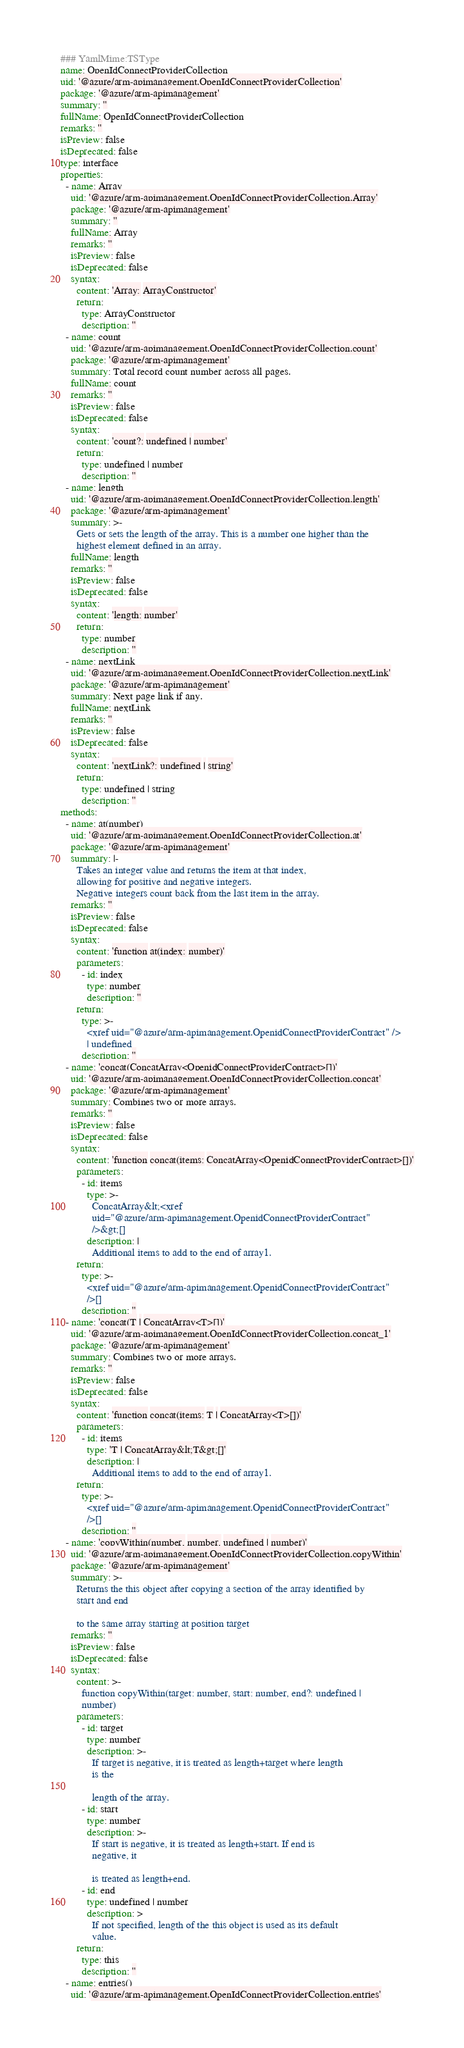<code> <loc_0><loc_0><loc_500><loc_500><_YAML_>### YamlMime:TSType
name: OpenIdConnectProviderCollection
uid: '@azure/arm-apimanagement.OpenIdConnectProviderCollection'
package: '@azure/arm-apimanagement'
summary: ''
fullName: OpenIdConnectProviderCollection
remarks: ''
isPreview: false
isDeprecated: false
type: interface
properties:
  - name: Array
    uid: '@azure/arm-apimanagement.OpenIdConnectProviderCollection.Array'
    package: '@azure/arm-apimanagement'
    summary: ''
    fullName: Array
    remarks: ''
    isPreview: false
    isDeprecated: false
    syntax:
      content: 'Array: ArrayConstructor'
      return:
        type: ArrayConstructor
        description: ''
  - name: count
    uid: '@azure/arm-apimanagement.OpenIdConnectProviderCollection.count'
    package: '@azure/arm-apimanagement'
    summary: Total record count number across all pages.
    fullName: count
    remarks: ''
    isPreview: false
    isDeprecated: false
    syntax:
      content: 'count?: undefined | number'
      return:
        type: undefined | number
        description: ''
  - name: length
    uid: '@azure/arm-apimanagement.OpenIdConnectProviderCollection.length'
    package: '@azure/arm-apimanagement'
    summary: >-
      Gets or sets the length of the array. This is a number one higher than the
      highest element defined in an array.
    fullName: length
    remarks: ''
    isPreview: false
    isDeprecated: false
    syntax:
      content: 'length: number'
      return:
        type: number
        description: ''
  - name: nextLink
    uid: '@azure/arm-apimanagement.OpenIdConnectProviderCollection.nextLink'
    package: '@azure/arm-apimanagement'
    summary: Next page link if any.
    fullName: nextLink
    remarks: ''
    isPreview: false
    isDeprecated: false
    syntax:
      content: 'nextLink?: undefined | string'
      return:
        type: undefined | string
        description: ''
methods:
  - name: at(number)
    uid: '@azure/arm-apimanagement.OpenIdConnectProviderCollection.at'
    package: '@azure/arm-apimanagement'
    summary: |-
      Takes an integer value and returns the item at that index,
      allowing for positive and negative integers.
      Negative integers count back from the last item in the array.
    remarks: ''
    isPreview: false
    isDeprecated: false
    syntax:
      content: 'function at(index: number)'
      parameters:
        - id: index
          type: number
          description: ''
      return:
        type: >-
          <xref uid="@azure/arm-apimanagement.OpenidConnectProviderContract" />
          | undefined
        description: ''
  - name: 'concat(ConcatArray<OpenidConnectProviderContract>[])'
    uid: '@azure/arm-apimanagement.OpenIdConnectProviderCollection.concat'
    package: '@azure/arm-apimanagement'
    summary: Combines two or more arrays.
    remarks: ''
    isPreview: false
    isDeprecated: false
    syntax:
      content: 'function concat(items: ConcatArray<OpenidConnectProviderContract>[])'
      parameters:
        - id: items
          type: >-
            ConcatArray&lt;<xref
            uid="@azure/arm-apimanagement.OpenidConnectProviderContract"
            />&gt;[]
          description: |
            Additional items to add to the end of array1.
      return:
        type: >-
          <xref uid="@azure/arm-apimanagement.OpenidConnectProviderContract"
          />[]
        description: ''
  - name: 'concat(T | ConcatArray<T>[])'
    uid: '@azure/arm-apimanagement.OpenIdConnectProviderCollection.concat_1'
    package: '@azure/arm-apimanagement'
    summary: Combines two or more arrays.
    remarks: ''
    isPreview: false
    isDeprecated: false
    syntax:
      content: 'function concat(items: T | ConcatArray<T>[])'
      parameters:
        - id: items
          type: 'T | ConcatArray&lt;T&gt;[]'
          description: |
            Additional items to add to the end of array1.
      return:
        type: >-
          <xref uid="@azure/arm-apimanagement.OpenidConnectProviderContract"
          />[]
        description: ''
  - name: 'copyWithin(number, number, undefined | number)'
    uid: '@azure/arm-apimanagement.OpenIdConnectProviderCollection.copyWithin'
    package: '@azure/arm-apimanagement'
    summary: >-
      Returns the this object after copying a section of the array identified by
      start and end

      to the same array starting at position target
    remarks: ''
    isPreview: false
    isDeprecated: false
    syntax:
      content: >-
        function copyWithin(target: number, start: number, end?: undefined |
        number)
      parameters:
        - id: target
          type: number
          description: >-
            If target is negative, it is treated as length+target where length
            is the

            length of the array.
        - id: start
          type: number
          description: >-
            If start is negative, it is treated as length+start. If end is
            negative, it

            is treated as length+end.
        - id: end
          type: undefined | number
          description: >
            If not specified, length of the this object is used as its default
            value.
      return:
        type: this
        description: ''
  - name: entries()
    uid: '@azure/arm-apimanagement.OpenIdConnectProviderCollection.entries'</code> 